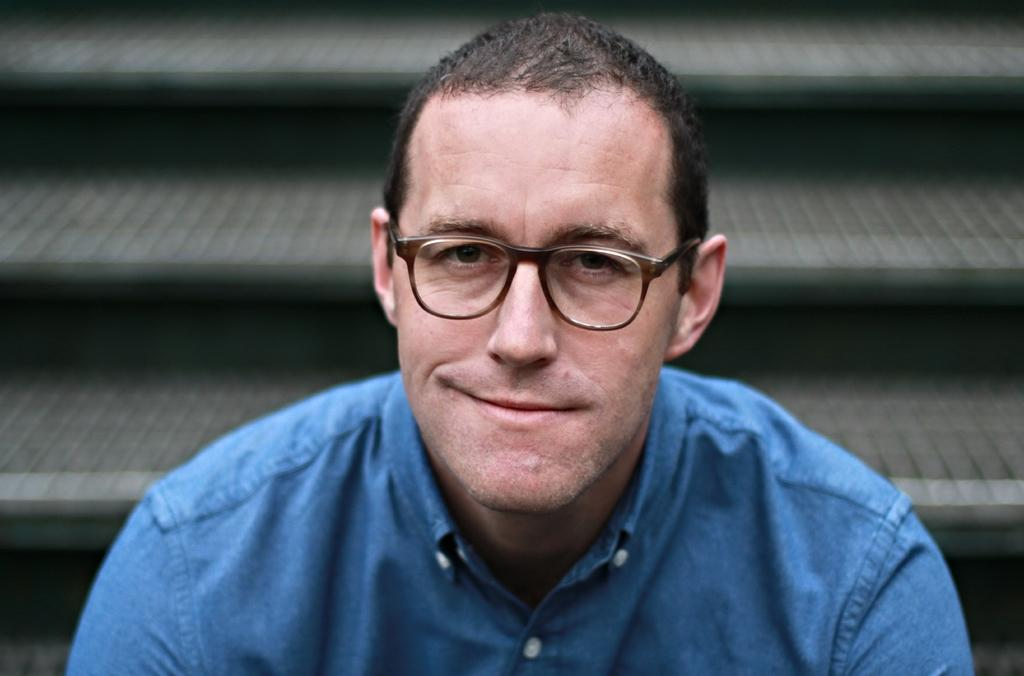Who is present in the image? There is a man in the image. What accessory is the man wearing? The man is wearing spectacles. What architectural feature can be seen in the background of the image? There are steps in the background of the image. How many apples are being cut with the knife in the image? There is no knife or apples present in the image. What type of frogs can be seen on the man's head in the image? There are no frogs present in the image; the man is wearing spectacles. 